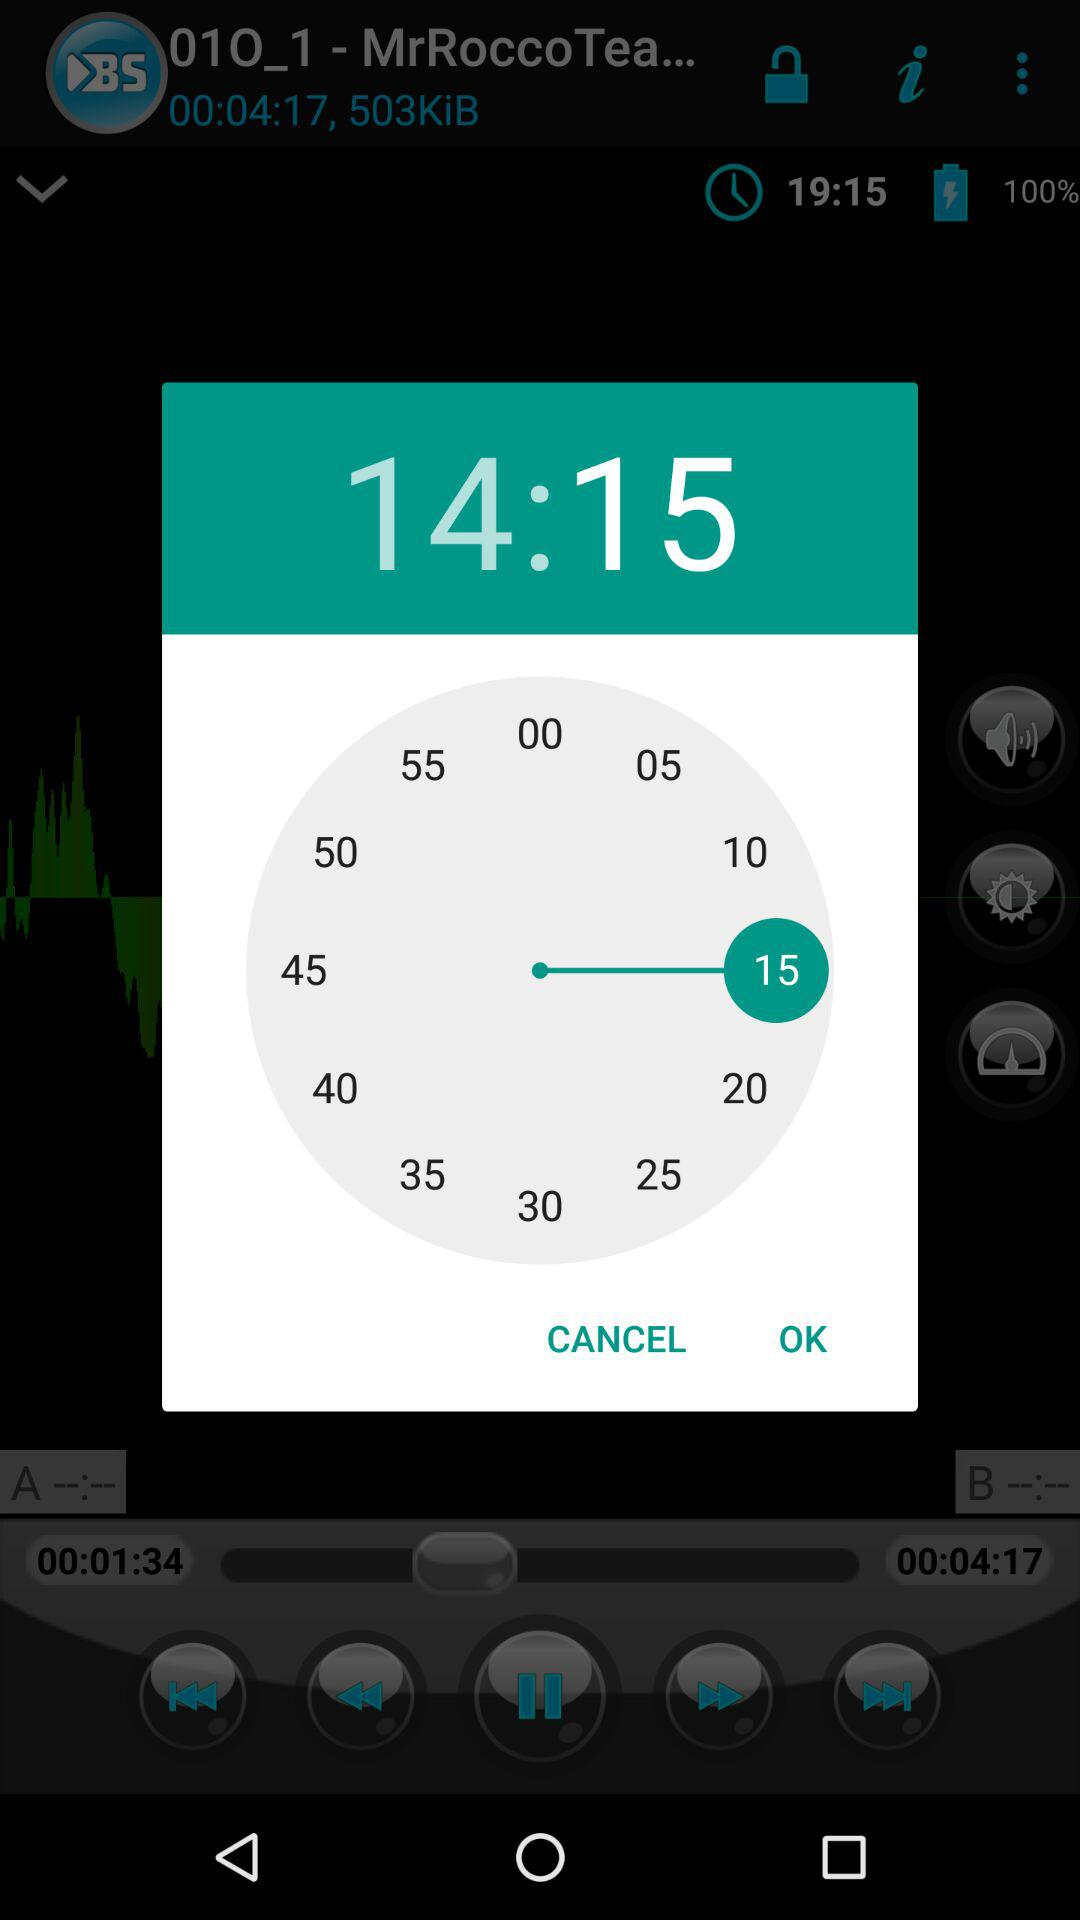What is the set time? The set time is 14:15. 